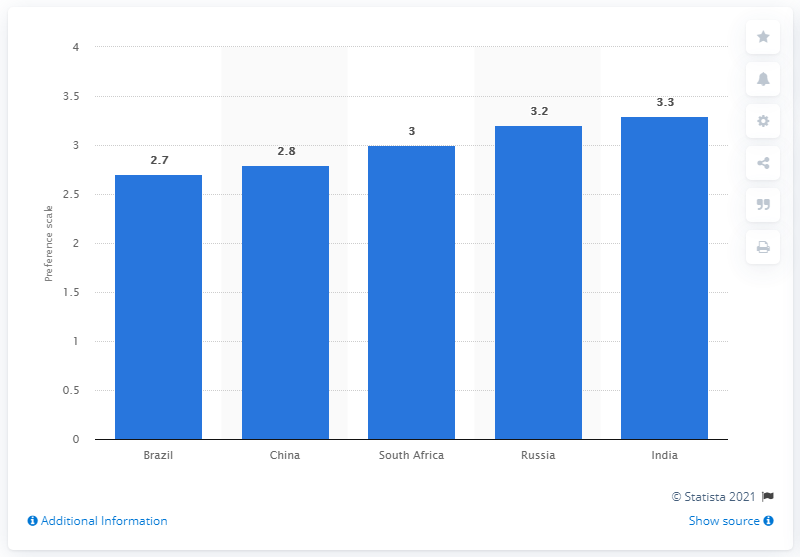Point out several critical features in this image. The most popular BRIC destination was Brazil. 